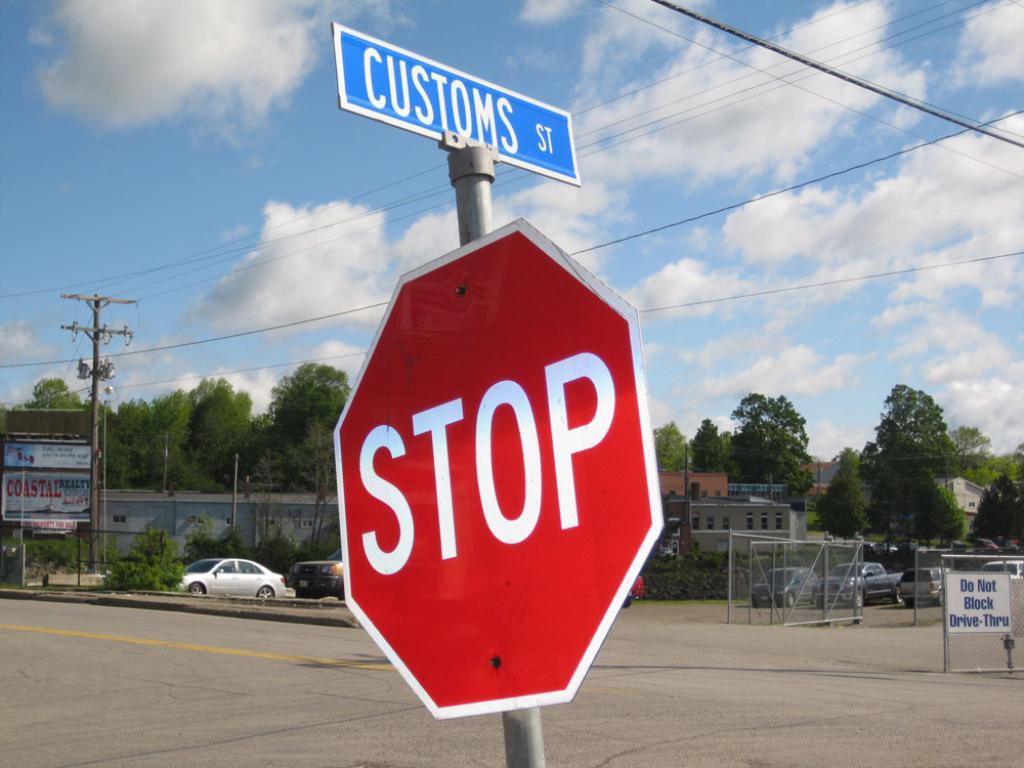<image>
Write a terse but informative summary of the picture. a stop sign that is outside with trees near 